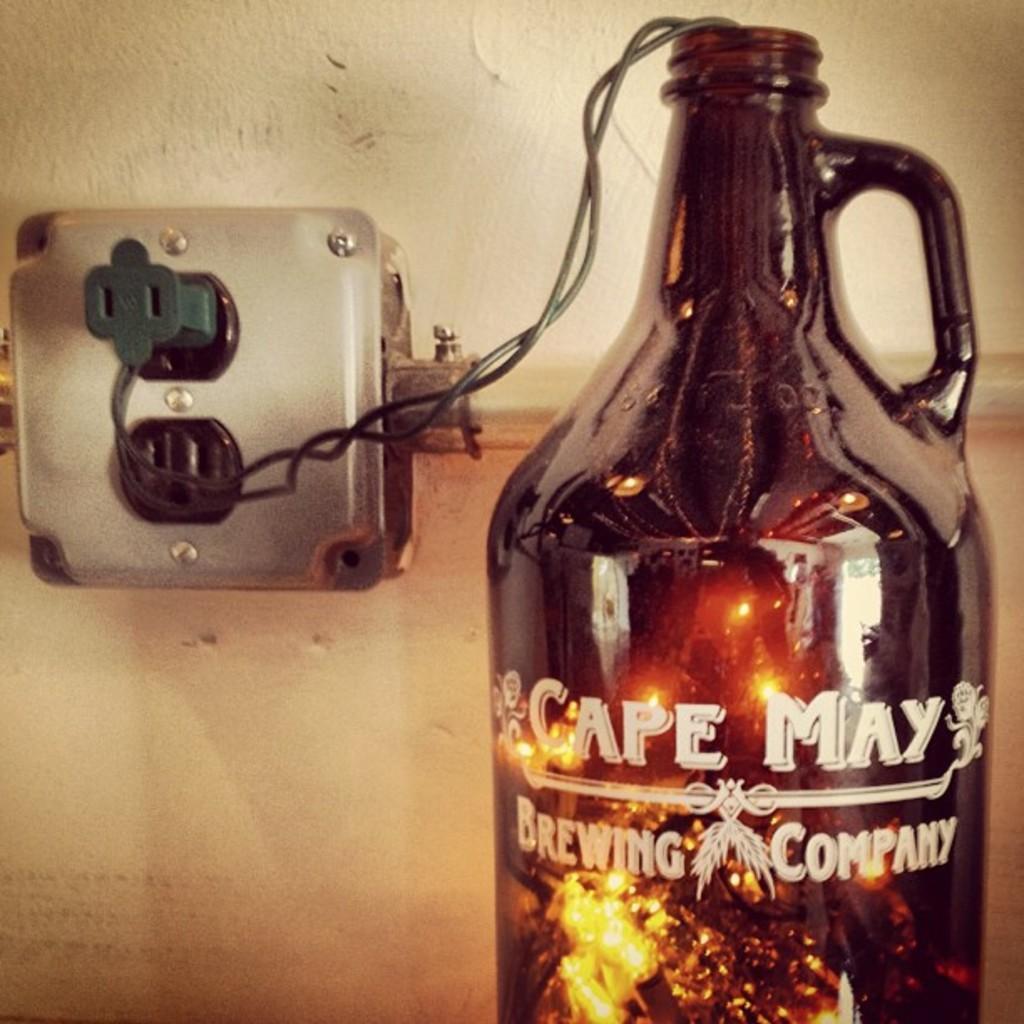Could you give a brief overview of what you see in this image? In this picture I can see a bottle and few lights in the bottle and I can see text on it and I can see a socket board on the wall. 